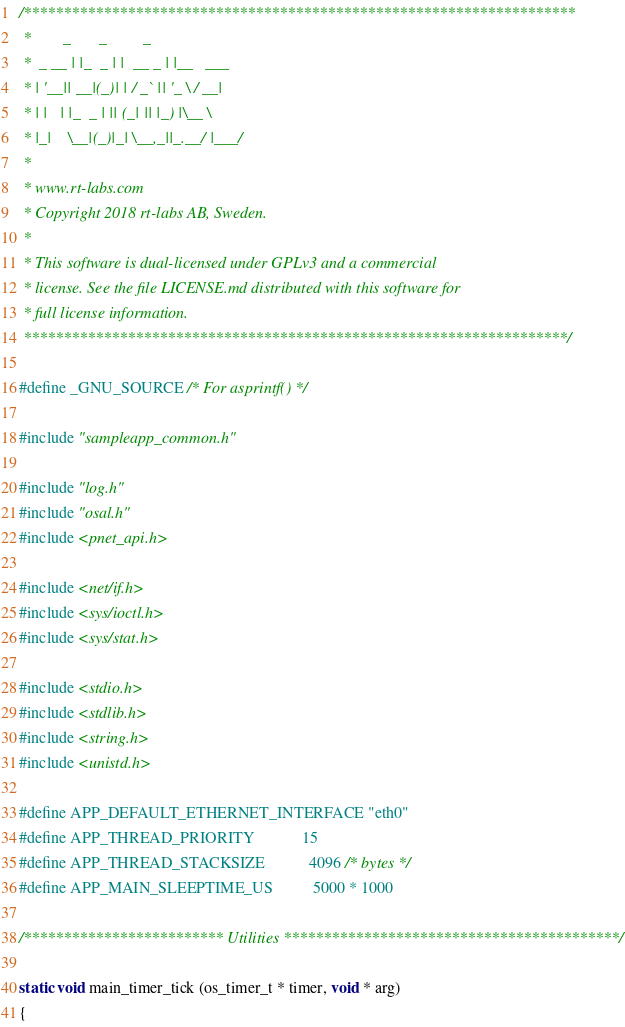Convert code to text. <code><loc_0><loc_0><loc_500><loc_500><_C_>/*********************************************************************
 *        _       _         _
 *  _ __ | |_  _ | |  __ _ | |__   ___
 * | '__|| __|(_)| | / _` || '_ \ / __|
 * | |   | |_  _ | || (_| || |_) |\__ \
 * |_|    \__|(_)|_| \__,_||_.__/ |___/
 *
 * www.rt-labs.com
 * Copyright 2018 rt-labs AB, Sweden.
 *
 * This software is dual-licensed under GPLv3 and a commercial
 * license. See the file LICENSE.md distributed with this software for
 * full license information.
 ********************************************************************/

#define _GNU_SOURCE /* For asprintf() */

#include "sampleapp_common.h"

#include "log.h"
#include "osal.h"
#include <pnet_api.h>

#include <net/if.h>
#include <sys/ioctl.h>
#include <sys/stat.h>

#include <stdio.h>
#include <stdlib.h>
#include <string.h>
#include <unistd.h>

#define APP_DEFAULT_ETHERNET_INTERFACE "eth0"
#define APP_THREAD_PRIORITY            15
#define APP_THREAD_STACKSIZE           4096 /* bytes */
#define APP_MAIN_SLEEPTIME_US          5000 * 1000

/************************* Utilities ******************************************/

static void main_timer_tick (os_timer_t * timer, void * arg)
{</code> 